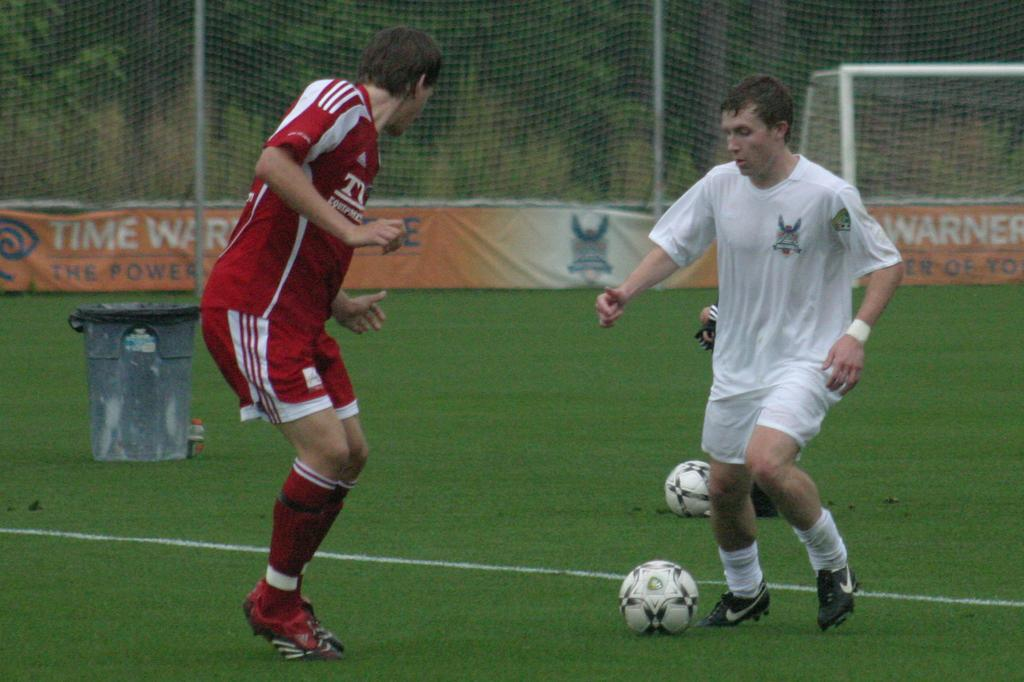<image>
Render a clear and concise summary of the photo. Two men are playing soccer in front of a Time Warner banner. 